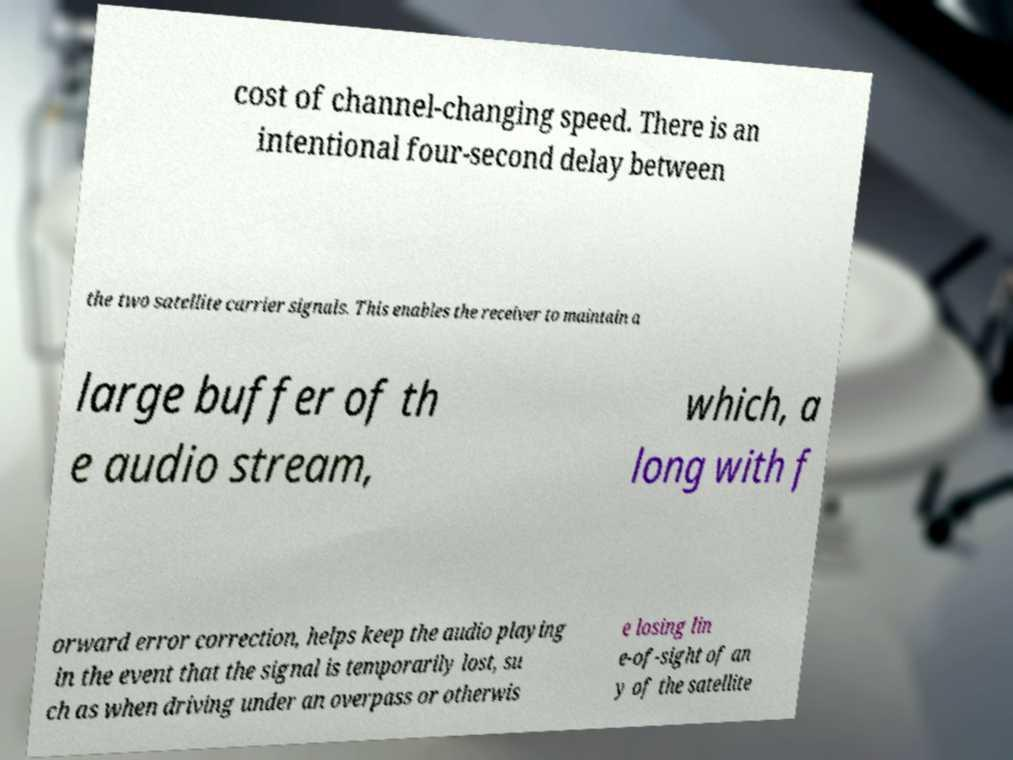Can you read and provide the text displayed in the image?This photo seems to have some interesting text. Can you extract and type it out for me? cost of channel-changing speed. There is an intentional four-second delay between the two satellite carrier signals. This enables the receiver to maintain a large buffer of th e audio stream, which, a long with f orward error correction, helps keep the audio playing in the event that the signal is temporarily lost, su ch as when driving under an overpass or otherwis e losing lin e-of-sight of an y of the satellite 